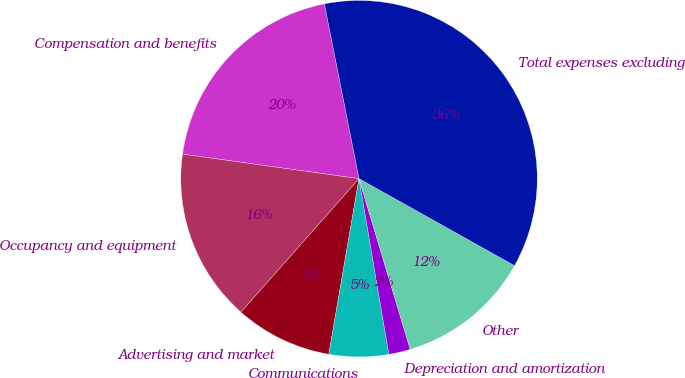<chart> <loc_0><loc_0><loc_500><loc_500><pie_chart><fcel>Compensation and benefits<fcel>Occupancy and equipment<fcel>Advertising and market<fcel>Communications<fcel>Depreciation and amortization<fcel>Other<fcel>Total expenses excluding<nl><fcel>19.69%<fcel>15.67%<fcel>8.82%<fcel>5.39%<fcel>1.96%<fcel>12.24%<fcel>36.23%<nl></chart> 